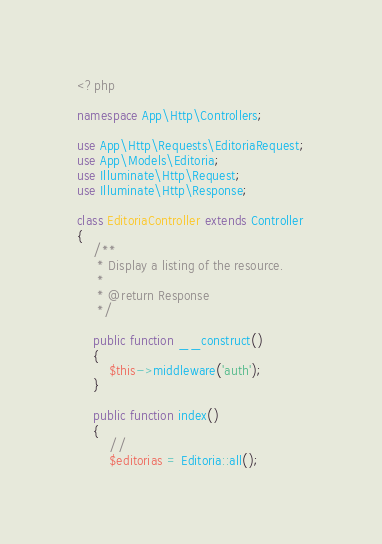<code> <loc_0><loc_0><loc_500><loc_500><_PHP_><?php

namespace App\Http\Controllers;

use App\Http\Requests\EditoriaRequest;
use App\Models\Editoria;
use Illuminate\Http\Request;
use Illuminate\Http\Response;

class EditoriaController extends Controller
{
    /**
     * Display a listing of the resource.
     *
     * @return Response
     */

    public function __construct()
    {
        $this->middleware('auth');
    }

    public function index()
    {
        //
        $editorias = Editoria::all();</code> 